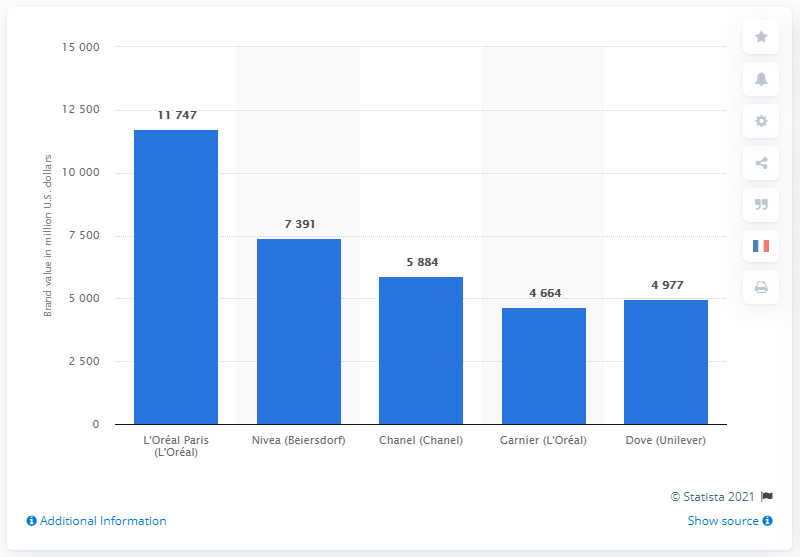Draw attention to some important aspects in this diagram. Nivea's brand value was approximately 7,391. 